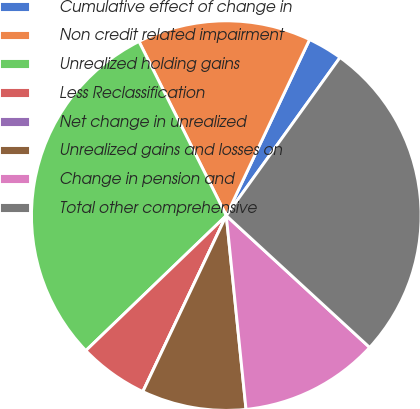Convert chart. <chart><loc_0><loc_0><loc_500><loc_500><pie_chart><fcel>Cumulative effect of change in<fcel>Non credit related impairment<fcel>Unrealized holding gains<fcel>Less Reclassification<fcel>Net change in unrealized<fcel>Unrealized gains and losses on<fcel>Change in pension and<fcel>Total other comprehensive<nl><fcel>2.89%<fcel>14.43%<fcel>29.79%<fcel>5.77%<fcel>0.0%<fcel>8.66%<fcel>11.55%<fcel>26.91%<nl></chart> 